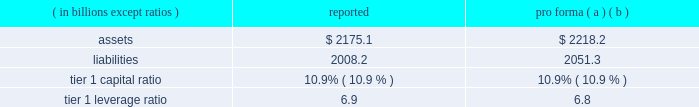Notes to consolidated financial statements 192 jpmorgan chase & co .
/ 2008 annual report consolidation analysis the multi-seller conduits administered by the firm were not consoli- dated at december 31 , 2008 and 2007 , because each conduit had issued expected loss notes ( 201celns 201d ) , the holders of which are com- mitted to absorbing the majority of the expected loss of each respective conduit .
Implied support the firm did not have and continues not to have any intent to pro- tect any eln holders from potential losses on any of the conduits 2019 holdings and has no plans to remove any assets from any conduit unless required to do so in its role as administrator .
Should such a transfer occur , the firm would allocate losses on such assets between itself and the eln holders in accordance with the terms of the applicable eln .
Expected loss modeling in determining the primary beneficiary of the conduits the firm uses a monte carlo 2013based model to estimate the expected losses of each of the conduits and considers the relative rights and obliga- tions of each of the variable interest holders .
The firm 2019s expected loss modeling treats all variable interests , other than the elns , as its own to determine consolidation .
The variability to be considered in the modeling of expected losses is based on the design of the enti- ty .
The firm 2019s traditional multi-seller conduits are designed to pass credit risk , not liquidity risk , to its variable interest holders , as the assets are intended to be held in the conduit for the longer term .
Under fin 46 ( r ) , the firm is required to run the monte carlo-based expected loss model each time a reconsideration event occurs .
In applying this guidance to the conduits , the following events , are considered to be reconsideration events , as they could affect the determination of the primary beneficiary of the conduits : 2022 new deals , including the issuance of new or additional variable interests ( credit support , liquidity facilities , etc ) ; 2022 changes in usage , including the change in the level of outstand- ing variable interests ( credit support , liquidity facilities , etc ) ; 2022 modifications of asset purchase agreements ; and 2022 sales of interests held by the primary beneficiary .
From an operational perspective , the firm does not run its monte carlo-based expected loss model every time there is a reconsideration event due to the frequency of their occurrence .
Instead , the firm runs its expected loss model each quarter and includes a growth assump- tion for each conduit to ensure that a sufficient amount of elns exists for each conduit at any point during the quarter .
As part of its normal quarterly modeling , the firm updates , when applicable , the inputs and assumptions used in the expected loss model .
Specifically , risk ratings and loss given default assumptions are continually updated .
The total amount of expected loss notes out- standing at december 31 , 2008 and 2007 , were $ 136 million and $ 130 million , respectively .
Management has concluded that the model assumptions used were reflective of market participants 2019 assumptions and appropriately considered the probability of changes to risk ratings and loss given defaults .
Qualitative considerations the multi-seller conduits are primarily designed to provide an effi- cient means for clients to access the commercial paper market .
The firm believes the conduits effectively disperse risk among all parties and that the preponderance of the economic risk in the firm 2019s multi- seller conduits is not held by jpmorgan chase .
Consolidated sensitivity analysis on capital the table below shows the impact on the firm 2019s reported assets , lia- bilities , tier 1 capital ratio and tier 1 leverage ratio if the firm were required to consolidate all of the multi-seller conduits that it admin- isters at their current carrying value .
December 31 , 2008 ( in billions , except ratios ) reported pro forma ( a ) ( b ) .
( a ) the table shows the impact of consolidating the assets and liabilities of the multi- seller conduits at their current carrying value ; as such , there would be no income statement or capital impact at the date of consolidation .
If the firm were required to consolidate the assets and liabilities of the conduits at fair value , the tier 1 capital ratio would be approximately 10.8% ( 10.8 % ) .
The fair value of the assets is primarily based upon pricing for comparable transactions .
The fair value of these assets could change significantly because the pricing of conduit transactions is renegotiated with the client , generally , on an annual basis and due to changes in current market conditions .
( b ) consolidation is assumed to occur on the first day of the quarter , at the quarter-end levels , in order to provide a meaningful adjustment to average assets in the denomi- nator of the leverage ratio .
The firm could fund purchases of assets from vies should it become necessary .
2007 activity in july 2007 , a reverse repurchase agreement collateralized by prime residential mortgages held by a firm-administered multi-seller conduit was put to jpmorgan chase under its deal-specific liquidity facility .
The asset was transferred to and recorded by jpmorgan chase at its par value based on the fair value of the collateral that supported the reverse repurchase agreement .
During the fourth quarter of 2007 , additional information regarding the value of the collateral , including performance statistics , resulted in the determi- nation by the firm that the fair value of the collateral was impaired .
Impairment losses were allocated to the eln holder ( the party that absorbs the majority of the expected loss from the conduit ) in accor- dance with the contractual provisions of the eln note .
On october 29 , 2007 , certain structured cdo assets originated in the second quarter of 2007 and backed by subprime mortgages were transferred to the firm from two firm-administered multi-seller conduits .
It became clear in october that commercial paper investors and rating agencies were becoming increasingly concerned about cdo assets backed by subprime mortgage exposures .
Because of these concerns , and to ensure the continuing viability of the two conduits as financing vehicles for clients and as investment alternatives for commercial paper investors , the firm , in its role as administrator , transferred the cdo assets out of the multi-seller con- duits .
The structured cdo assets were transferred to the firm at .
By how many basis points would the tier 1 capital ratio improve if the firm were to consolidate the assets and liabilities of the conduits at fair value? 
Computations: ((10.9 - 10.8) * 100)
Answer: 10.0. 